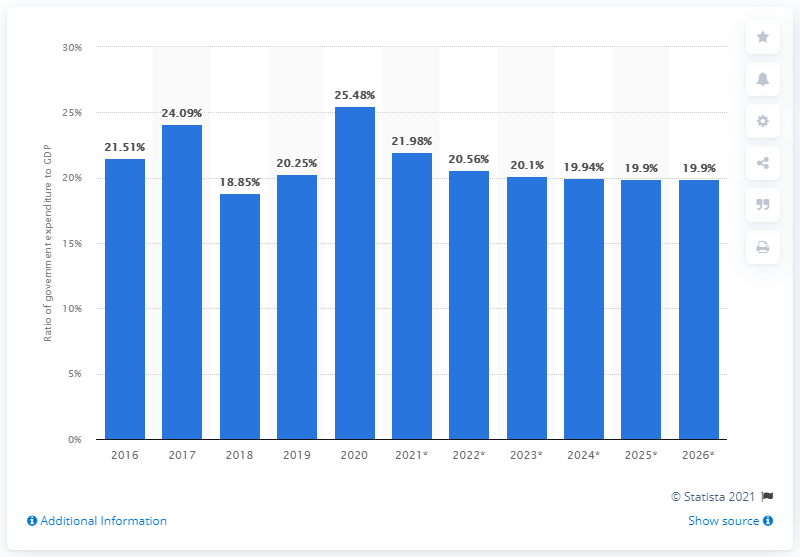Identify some key points in this picture. In 2020, approximately 25.48% of Kazakhstan's Gross Domestic Product (GDP) was allocated for government expenditure. 